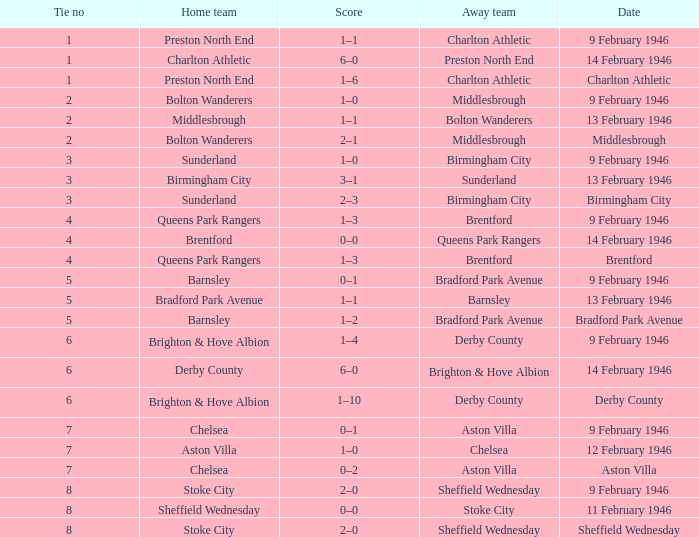Parse the table in full. {'header': ['Tie no', 'Home team', 'Score', 'Away team', 'Date'], 'rows': [['1', 'Preston North End', '1–1', 'Charlton Athletic', '9 February 1946'], ['1', 'Charlton Athletic', '6–0', 'Preston North End', '14 February 1946'], ['1', 'Preston North End', '1–6', 'Charlton Athletic', 'Charlton Athletic'], ['2', 'Bolton Wanderers', '1–0', 'Middlesbrough', '9 February 1946'], ['2', 'Middlesbrough', '1–1', 'Bolton Wanderers', '13 February 1946'], ['2', 'Bolton Wanderers', '2–1', 'Middlesbrough', 'Middlesbrough'], ['3', 'Sunderland', '1–0', 'Birmingham City', '9 February 1946'], ['3', 'Birmingham City', '3–1', 'Sunderland', '13 February 1946'], ['3', 'Sunderland', '2–3', 'Birmingham City', 'Birmingham City'], ['4', 'Queens Park Rangers', '1–3', 'Brentford', '9 February 1946'], ['4', 'Brentford', '0–0', 'Queens Park Rangers', '14 February 1946'], ['4', 'Queens Park Rangers', '1–3', 'Brentford', 'Brentford'], ['5', 'Barnsley', '0–1', 'Bradford Park Avenue', '9 February 1946'], ['5', 'Bradford Park Avenue', '1–1', 'Barnsley', '13 February 1946'], ['5', 'Barnsley', '1–2', 'Bradford Park Avenue', 'Bradford Park Avenue'], ['6', 'Brighton & Hove Albion', '1–4', 'Derby County', '9 February 1946'], ['6', 'Derby County', '6–0', 'Brighton & Hove Albion', '14 February 1946'], ['6', 'Brighton & Hove Albion', '1–10', 'Derby County', 'Derby County'], ['7', 'Chelsea', '0–1', 'Aston Villa', '9 February 1946'], ['7', 'Aston Villa', '1–0', 'Chelsea', '12 February 1946'], ['7', 'Chelsea', '0–2', 'Aston Villa', 'Aston Villa'], ['8', 'Stoke City', '2–0', 'Sheffield Wednesday', '9 February 1946'], ['8', 'Sheffield Wednesday', '0–0', 'Stoke City', '11 February 1946'], ['8', 'Stoke City', '2–0', 'Sheffield Wednesday', 'Sheffield Wednesday']]} What was the Tie no when then home team was Stoke City for the game played on 9 February 1946? 8.0. 